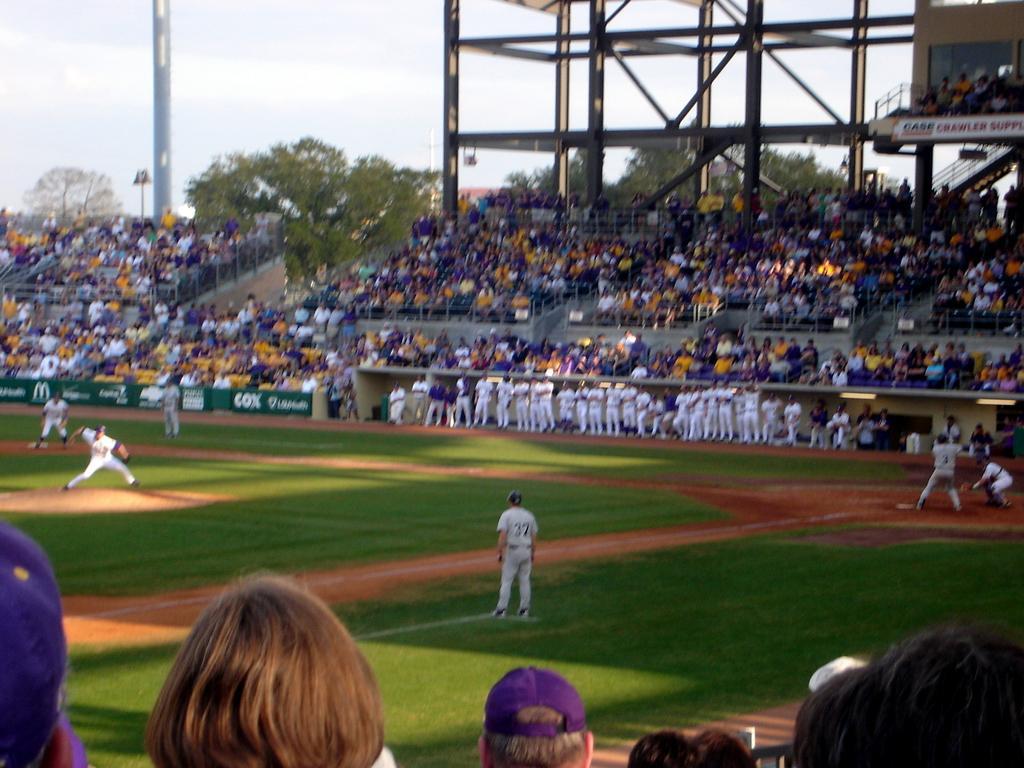Describe this image in one or two sentences. In the picture we can see a stadium with a ground and some parts with green color mat and some people are playing a baseball and they are in sports wear and around the ground we can see audience sitting on the chairs and in the background we can see some trees, poles and sky. 